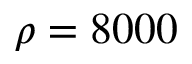Convert formula to latex. <formula><loc_0><loc_0><loc_500><loc_500>\rho = 8 0 0 0</formula> 